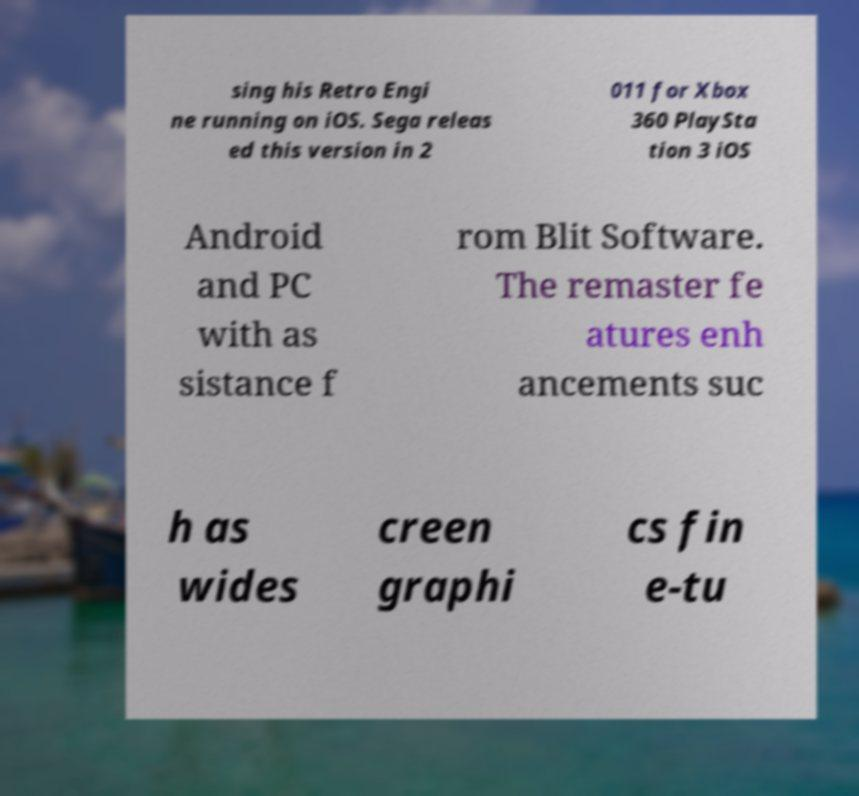For documentation purposes, I need the text within this image transcribed. Could you provide that? sing his Retro Engi ne running on iOS. Sega releas ed this version in 2 011 for Xbox 360 PlaySta tion 3 iOS Android and PC with as sistance f rom Blit Software. The remaster fe atures enh ancements suc h as wides creen graphi cs fin e-tu 